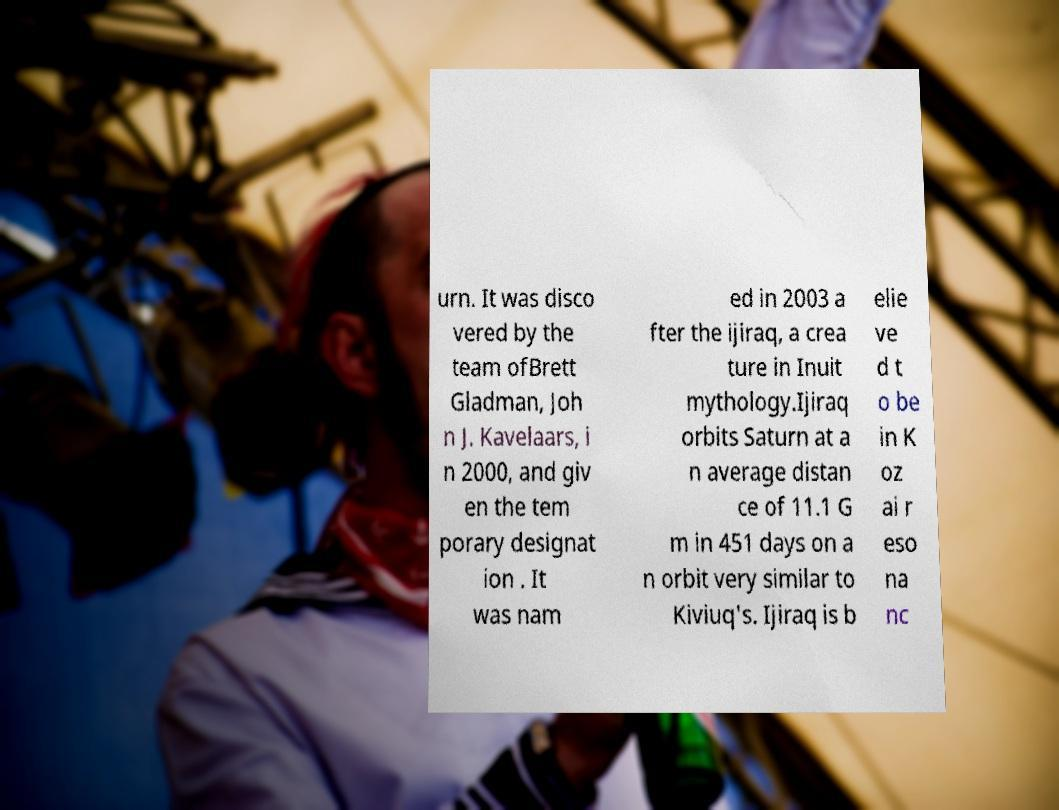Please read and relay the text visible in this image. What does it say? urn. It was disco vered by the team ofBrett Gladman, Joh n J. Kavelaars, i n 2000, and giv en the tem porary designat ion . It was nam ed in 2003 a fter the ijiraq, a crea ture in Inuit mythology.Ijiraq orbits Saturn at a n average distan ce of 11.1 G m in 451 days on a n orbit very similar to Kiviuq's. Ijiraq is b elie ve d t o be in K oz ai r eso na nc 